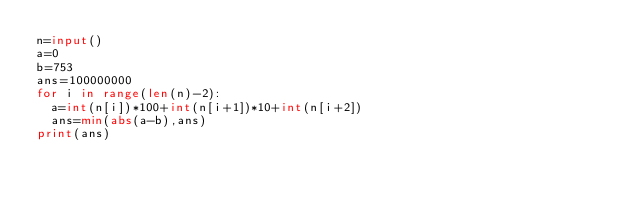Convert code to text. <code><loc_0><loc_0><loc_500><loc_500><_Python_>n=input()
a=0
b=753
ans=100000000
for i in range(len(n)-2):
	a=int(n[i])*100+int(n[i+1])*10+int(n[i+2])
	ans=min(abs(a-b),ans)
print(ans)</code> 